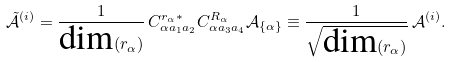Convert formula to latex. <formula><loc_0><loc_0><loc_500><loc_500>\tilde { \mathcal { A } } ^ { ( i ) } = \frac { 1 } { \text {dim} ( r _ { \alpha } ) } \, C ^ { r _ { \alpha } \ast } _ { \alpha a _ { 1 } a _ { 2 } } C ^ { R _ { \alpha } } _ { \alpha a _ { 3 } a _ { 4 } } \mathcal { A } _ { \{ \alpha \} } \equiv \frac { 1 } { \sqrt { \text {dim} ( r _ { \alpha } ) } } \, \mathcal { A } ^ { ( i ) } .</formula> 